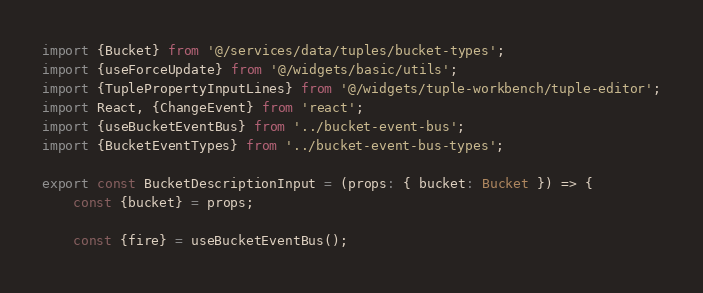<code> <loc_0><loc_0><loc_500><loc_500><_TypeScript_>import {Bucket} from '@/services/data/tuples/bucket-types';
import {useForceUpdate} from '@/widgets/basic/utils';
import {TuplePropertyInputLines} from '@/widgets/tuple-workbench/tuple-editor';
import React, {ChangeEvent} from 'react';
import {useBucketEventBus} from '../bucket-event-bus';
import {BucketEventTypes} from '../bucket-event-bus-types';

export const BucketDescriptionInput = (props: { bucket: Bucket }) => {
	const {bucket} = props;

	const {fire} = useBucketEventBus();</code> 